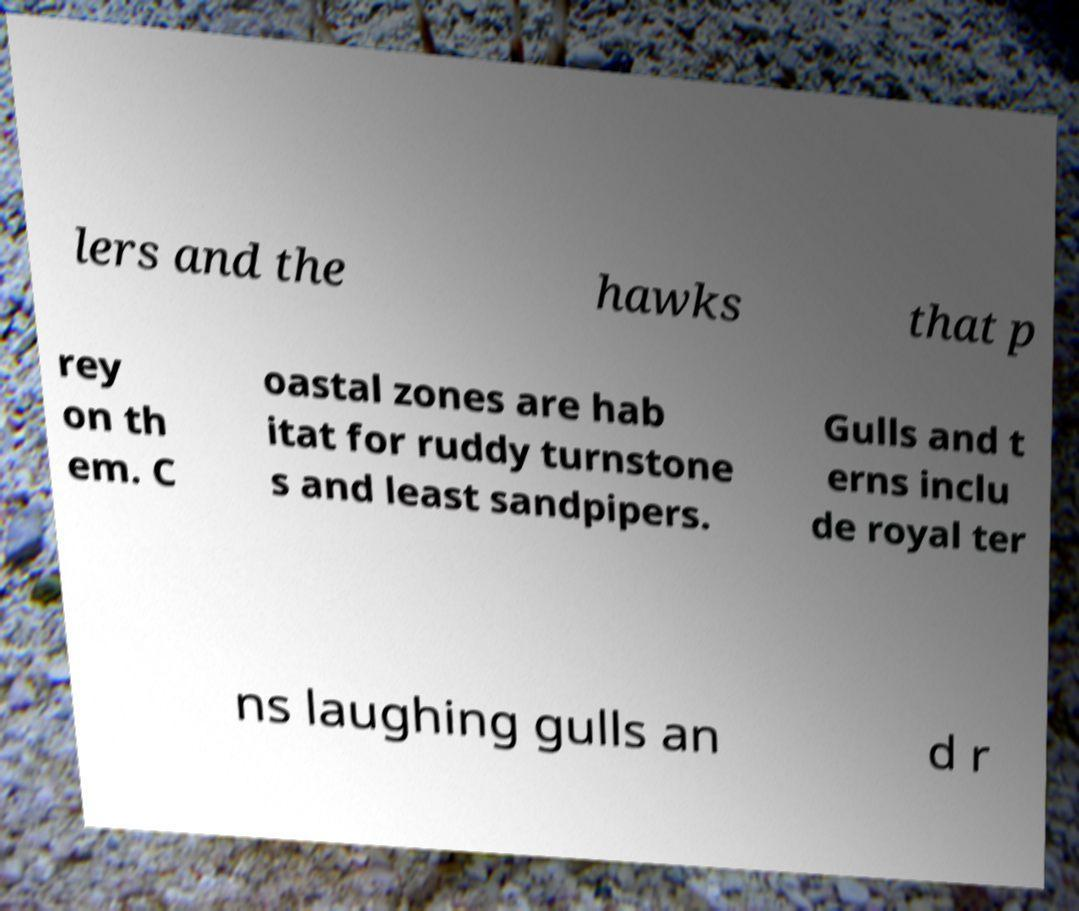Could you assist in decoding the text presented in this image and type it out clearly? lers and the hawks that p rey on th em. C oastal zones are hab itat for ruddy turnstone s and least sandpipers. Gulls and t erns inclu de royal ter ns laughing gulls an d r 